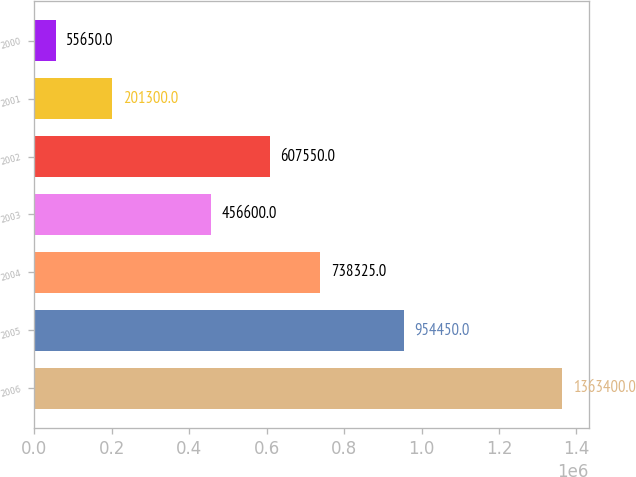Convert chart to OTSL. <chart><loc_0><loc_0><loc_500><loc_500><bar_chart><fcel>2006<fcel>2005<fcel>2004<fcel>2003<fcel>2002<fcel>2001<fcel>2000<nl><fcel>1.3634e+06<fcel>954450<fcel>738325<fcel>456600<fcel>607550<fcel>201300<fcel>55650<nl></chart> 